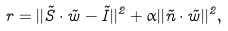Convert formula to latex. <formula><loc_0><loc_0><loc_500><loc_500>r = | | \vec { S } \cdot \vec { w } - \vec { I } | | ^ { 2 } + \alpha | | \vec { n } \cdot \vec { w } | | ^ { 2 } ,</formula> 